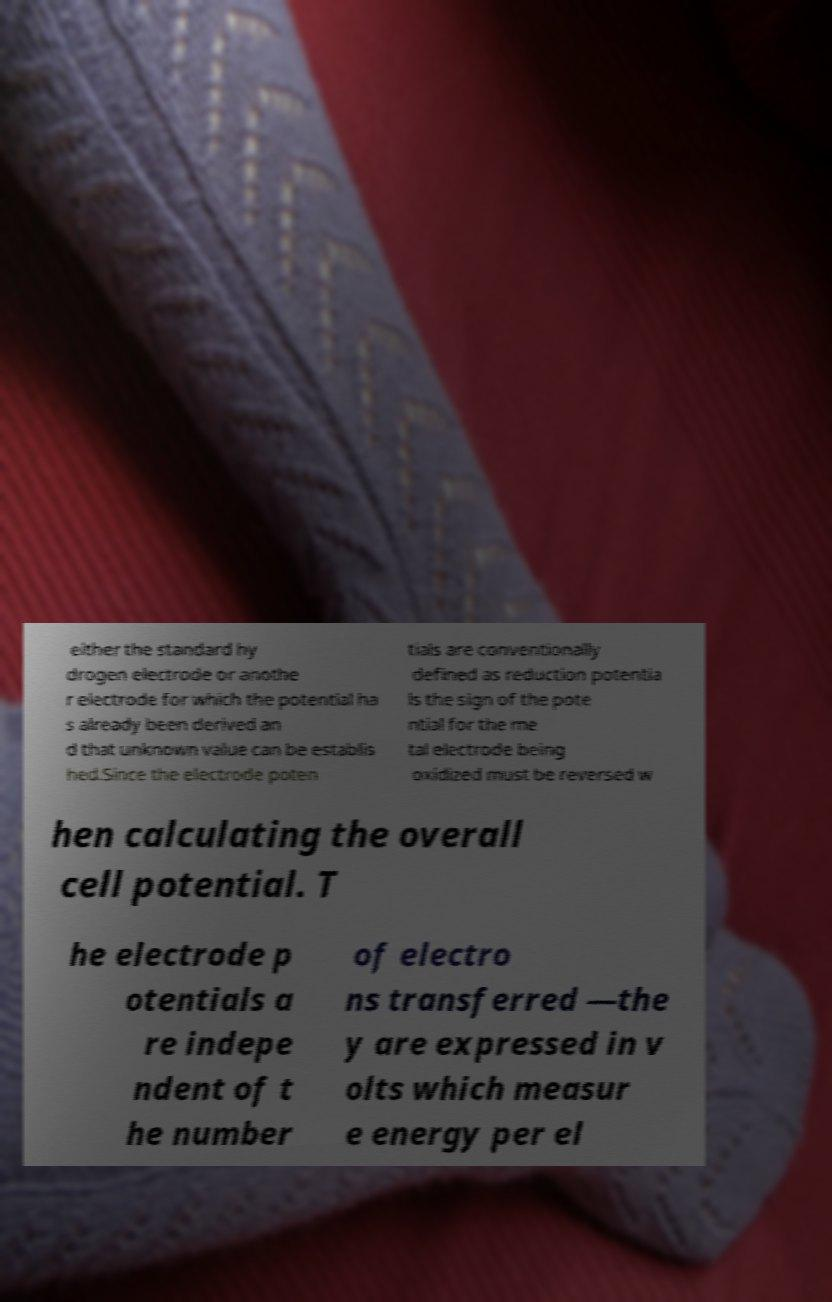Can you read and provide the text displayed in the image?This photo seems to have some interesting text. Can you extract and type it out for me? either the standard hy drogen electrode or anothe r electrode for which the potential ha s already been derived an d that unknown value can be establis hed.Since the electrode poten tials are conventionally defined as reduction potentia ls the sign of the pote ntial for the me tal electrode being oxidized must be reversed w hen calculating the overall cell potential. T he electrode p otentials a re indepe ndent of t he number of electro ns transferred —the y are expressed in v olts which measur e energy per el 